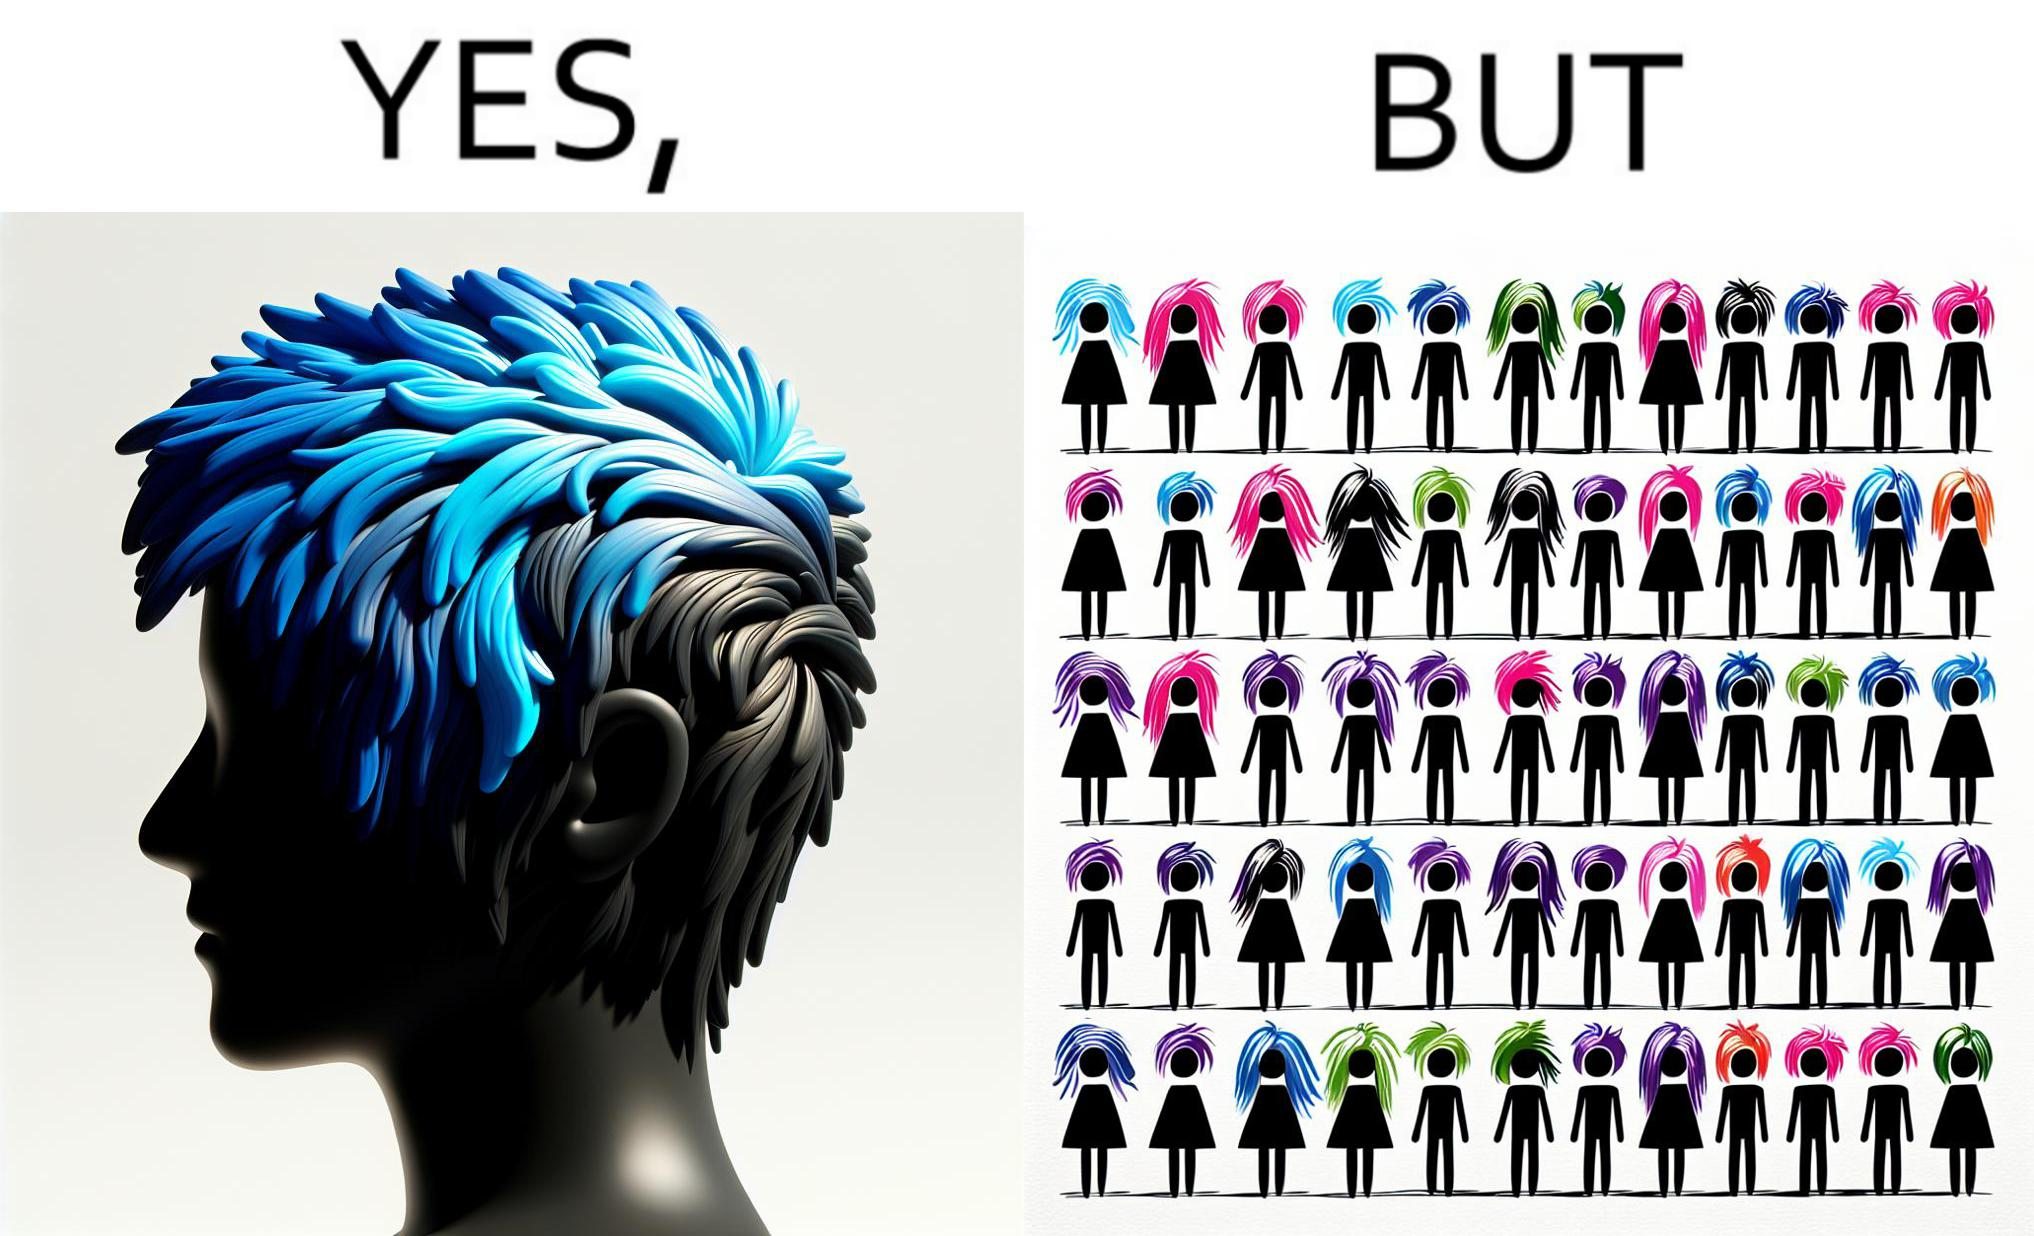Provide a description of this image. The image is funny, as one person with a hair dyed blue seems to symbolize that the person is going against the grain, however, when we zoom out, the group of people have hair dyed in several, different colors, showing that, dyeing hair is the new normal. 